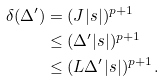Convert formula to latex. <formula><loc_0><loc_0><loc_500><loc_500>\delta ( \Delta ^ { \prime } ) & = ( J | s | ) ^ { p + 1 } \\ & \leq ( \Delta ^ { \prime } | s | ) ^ { p + 1 } \\ & \leq ( L \Delta ^ { \prime } | s | ) ^ { p + 1 } \, .</formula> 